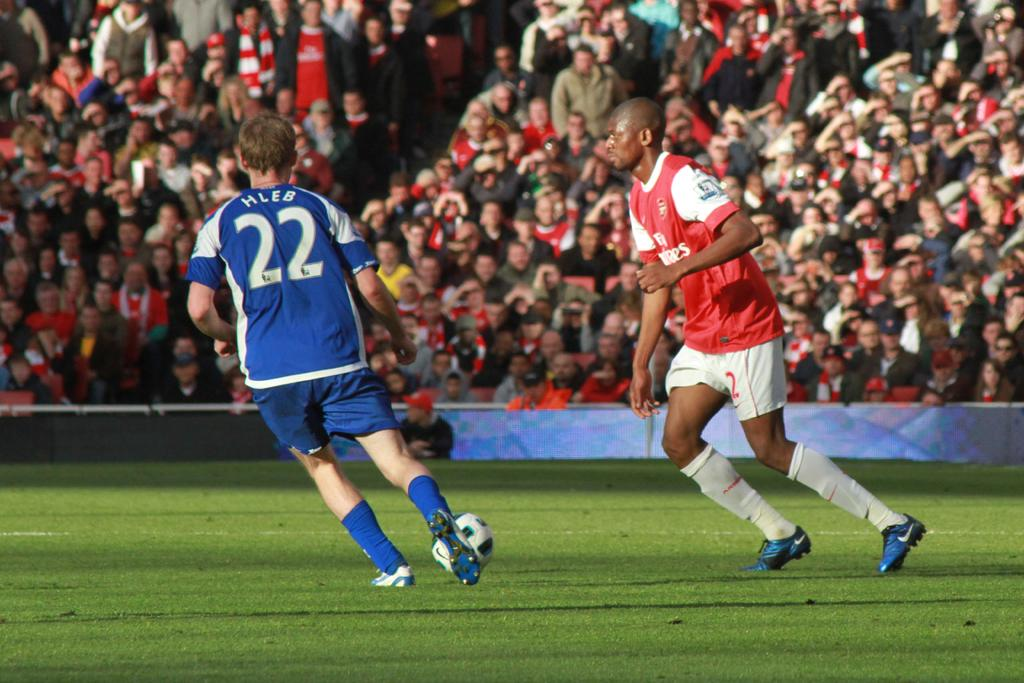<image>
Render a clear and concise summary of the photo. Player number 22, named HLEB, leans to his left as he runs. 